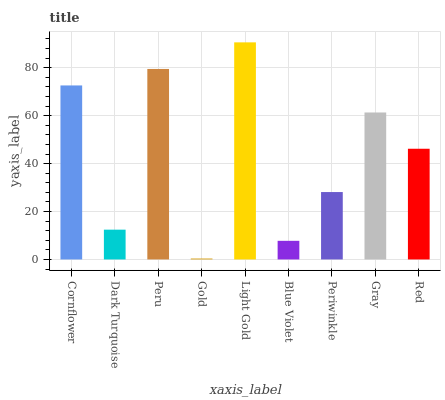Is Gold the minimum?
Answer yes or no. Yes. Is Light Gold the maximum?
Answer yes or no. Yes. Is Dark Turquoise the minimum?
Answer yes or no. No. Is Dark Turquoise the maximum?
Answer yes or no. No. Is Cornflower greater than Dark Turquoise?
Answer yes or no. Yes. Is Dark Turquoise less than Cornflower?
Answer yes or no. Yes. Is Dark Turquoise greater than Cornflower?
Answer yes or no. No. Is Cornflower less than Dark Turquoise?
Answer yes or no. No. Is Red the high median?
Answer yes or no. Yes. Is Red the low median?
Answer yes or no. Yes. Is Peru the high median?
Answer yes or no. No. Is Periwinkle the low median?
Answer yes or no. No. 